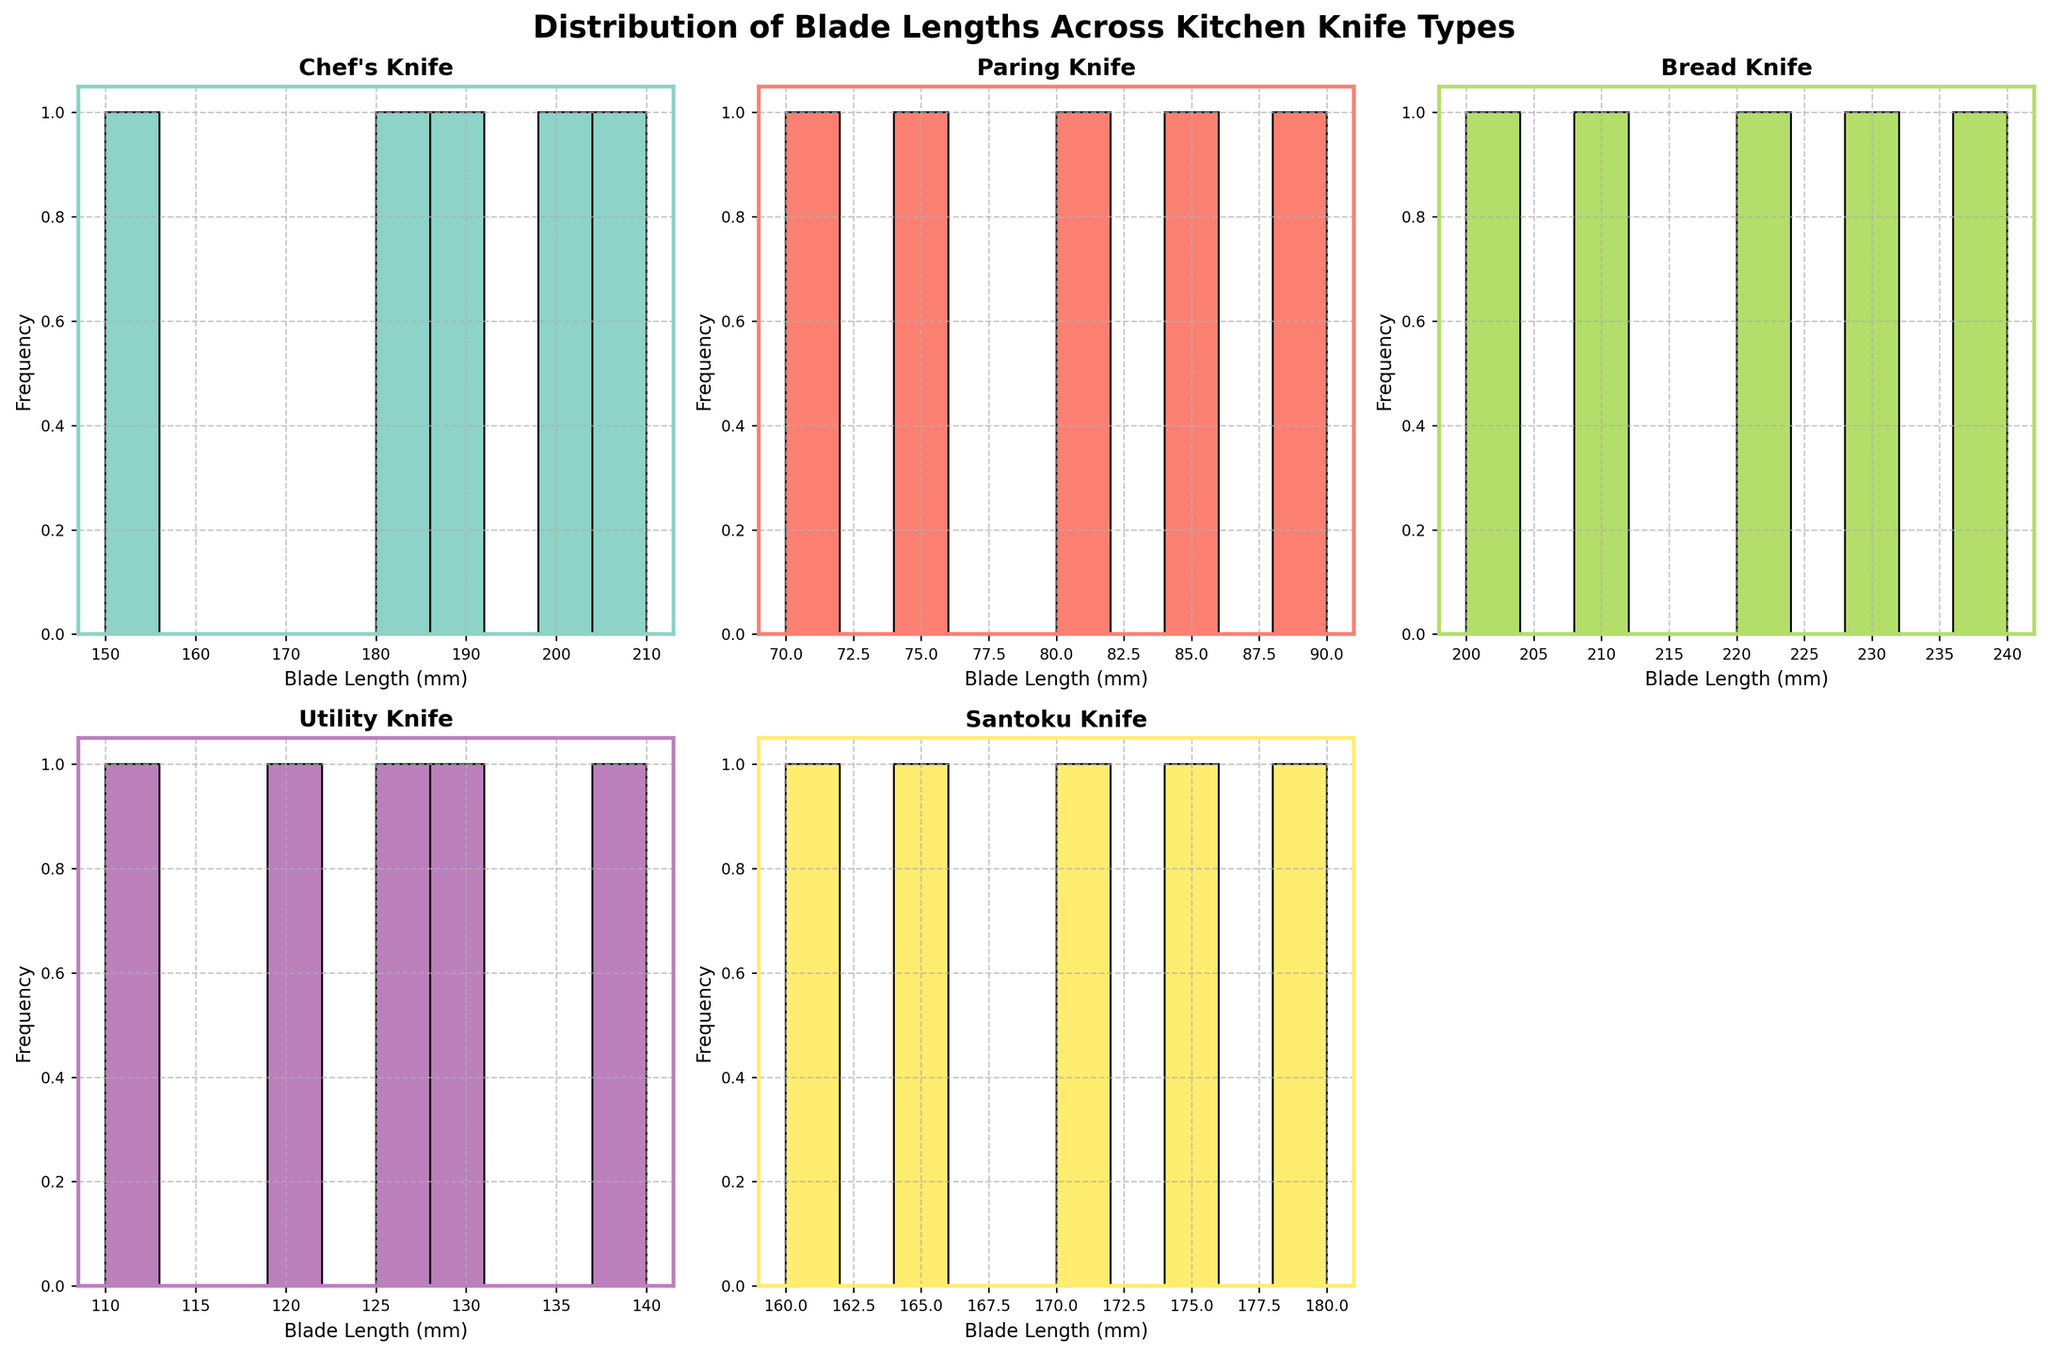What's the title of the figure? The title is provided at the top of the figure and reads "Distribution of Blade Lengths Across Kitchen Knife Types."
Answer: Distribution of Blade Lengths Across Kitchen Knife Types How many types of kitchen knives are shown in the plots? The plots illustrate five unique kitchen knife types: Chef's Knife, Paring Knife, Bread Knife, Utility Knife, and Santoku Knife
Answer: 5 Which knife type has the longest blade length shown in the histograms? By looking at the x-axis of each subplot, the Bread Knife histogram shows blade lengths that reach up to 240mm, the longest among all kitchen knives displayed.
Answer: Bread Knife What is the range of blade lengths for the Paring Knife? Examining the x-axis of the Paring Knife subplot, the blade lengths range from 70mm to 90mm.
Answer: 70mm to 90mm Which knife type has the most evenly distributed blade lengths across the bins? By comparing the histograms, the Chef’s Knife and Santoku Knife show blade lengths that are more evenly distributed across the bins, unlike other types which show clustered lengths. However, the Santoku Knife seems slightly more evenly spread out.
Answer: Santoku Knife How does the distribution of blade lengths for the Utility Knife compare to the Chef’s Knife? The blade lengths for the Utility Knife range from 110mm to 140mm, while the Chef’s Knife ranges from 150mm to 210mm. This shows that Chef’s Knives typically have longer blade lengths, and the distribution is more spread out than the Utility Knife.
Answer: Chef’s Knives are longer and more varied Which knife type has the highest frequency for the shortest blade length bin? The histogram for the Paring Knife shows the highest frequency for the bin at 70mm, with noticeably higher frequencies than the other types for their respective shortest lengths.
Answer: Paring Knife What can you infer about the blade lengths of Bread Knives based on the histogram? Observing the Bread Knife histogram, the blade lengths cluster towards the higher end, with lengths predominantly ranging from 200mm to 240mm. This indicates Bread Knives typically have longer blades compared to other types.
Answer: Bread Knives have longer blades Is there any redundant subplot in the figure? If so, which one? Yes, one subplot space (bottom right) is blank or removed, indicating it was not used for displaying data.
Answer: Bottom right subplot is removed 